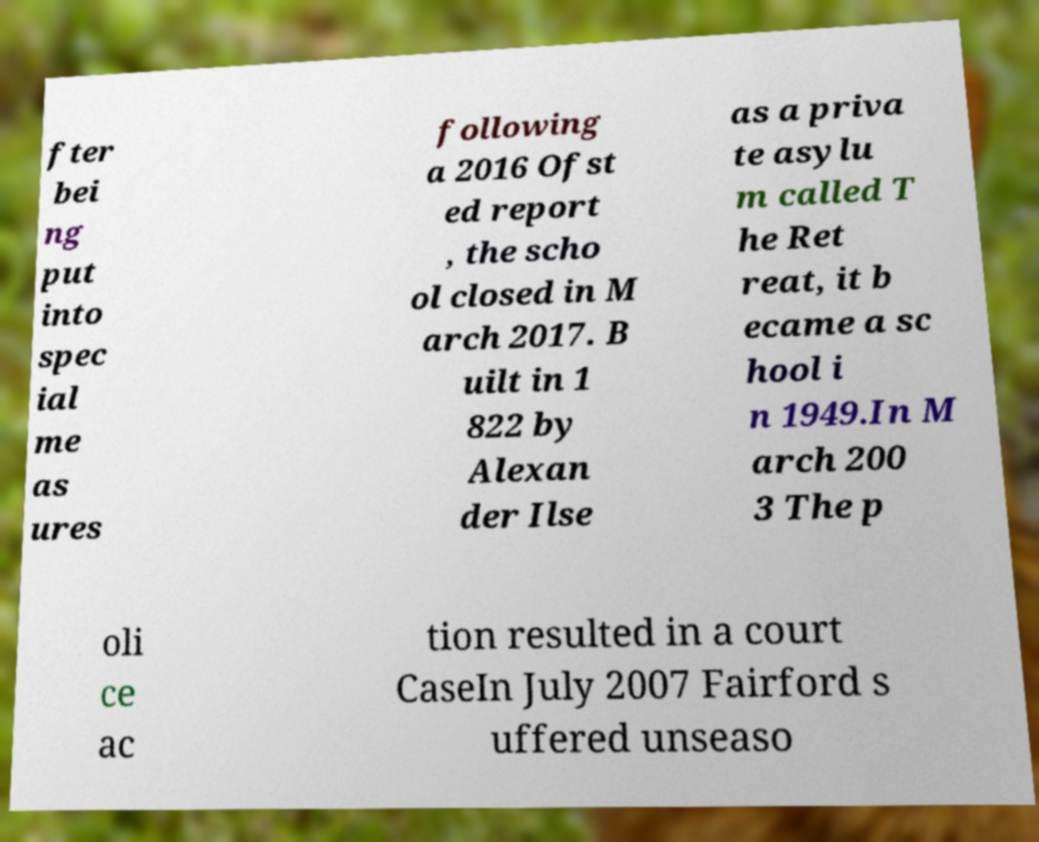Can you read and provide the text displayed in the image?This photo seems to have some interesting text. Can you extract and type it out for me? fter bei ng put into spec ial me as ures following a 2016 Ofst ed report , the scho ol closed in M arch 2017. B uilt in 1 822 by Alexan der Ilse as a priva te asylu m called T he Ret reat, it b ecame a sc hool i n 1949.In M arch 200 3 The p oli ce ac tion resulted in a court CaseIn July 2007 Fairford s uffered unseaso 